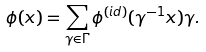<formula> <loc_0><loc_0><loc_500><loc_500>\phi ( x ) = \sum _ { \gamma \in \Gamma } \phi ^ { ( i d ) } ( \gamma ^ { - 1 } x ) \gamma .</formula> 